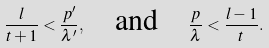Convert formula to latex. <formula><loc_0><loc_0><loc_500><loc_500>\frac { l } { t + 1 } < \frac { p ^ { \prime } } { \lambda ^ { \prime } } , \quad \text {and} \quad \frac { p } { \lambda } < \frac { l - 1 } { t } .</formula> 